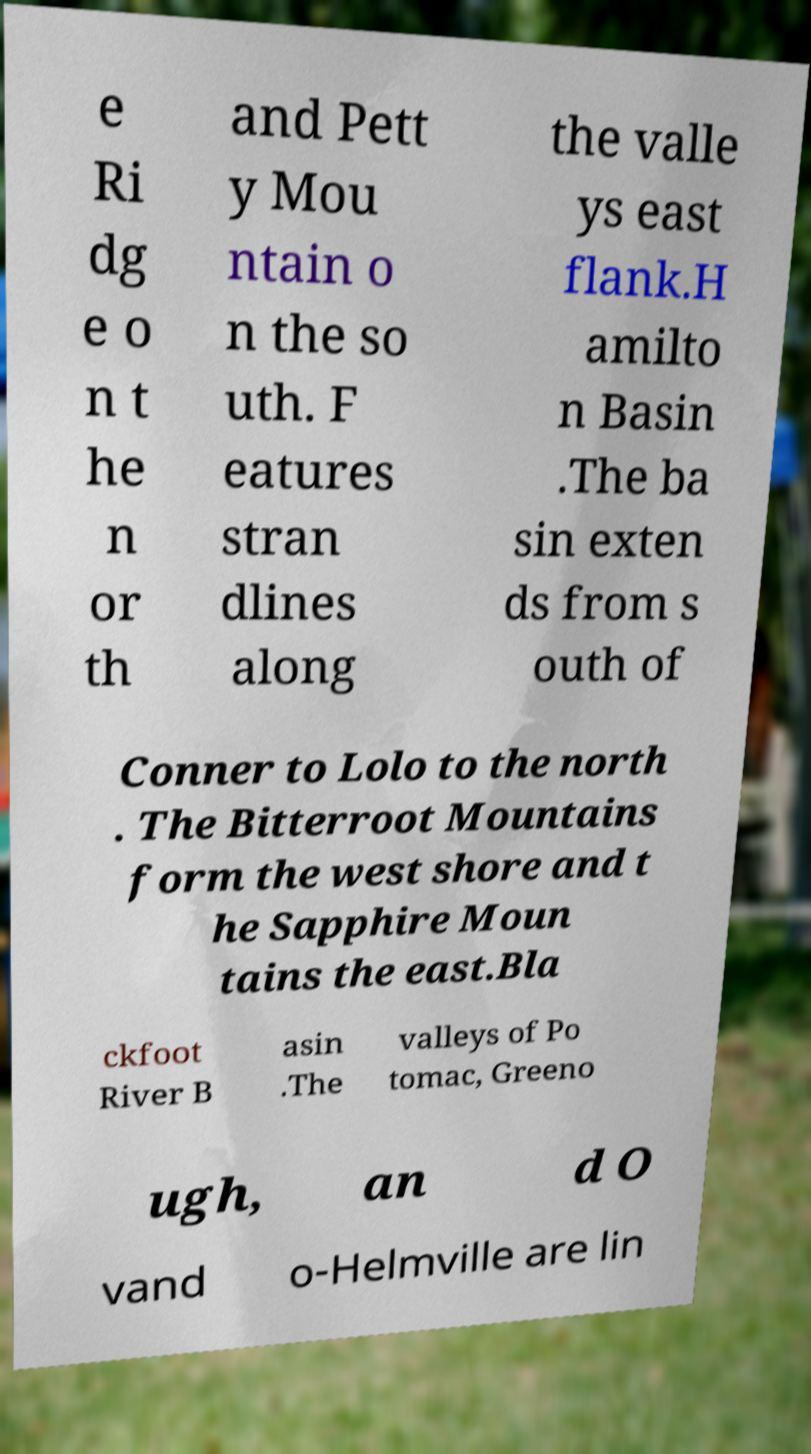Please identify and transcribe the text found in this image. e Ri dg e o n t he n or th and Pett y Mou ntain o n the so uth. F eatures stran dlines along the valle ys east flank.H amilto n Basin .The ba sin exten ds from s outh of Conner to Lolo to the north . The Bitterroot Mountains form the west shore and t he Sapphire Moun tains the east.Bla ckfoot River B asin .The valleys of Po tomac, Greeno ugh, an d O vand o-Helmville are lin 